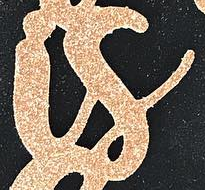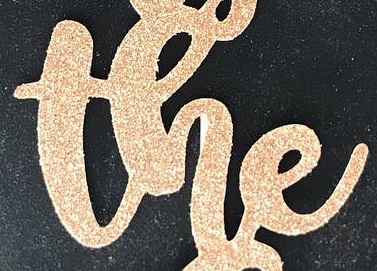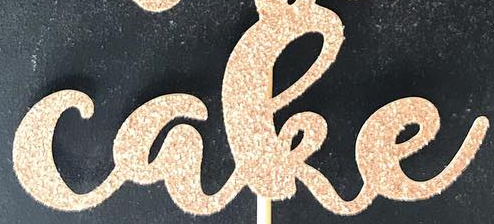What text appears in these images from left to right, separated by a semicolon? is; the; cake 